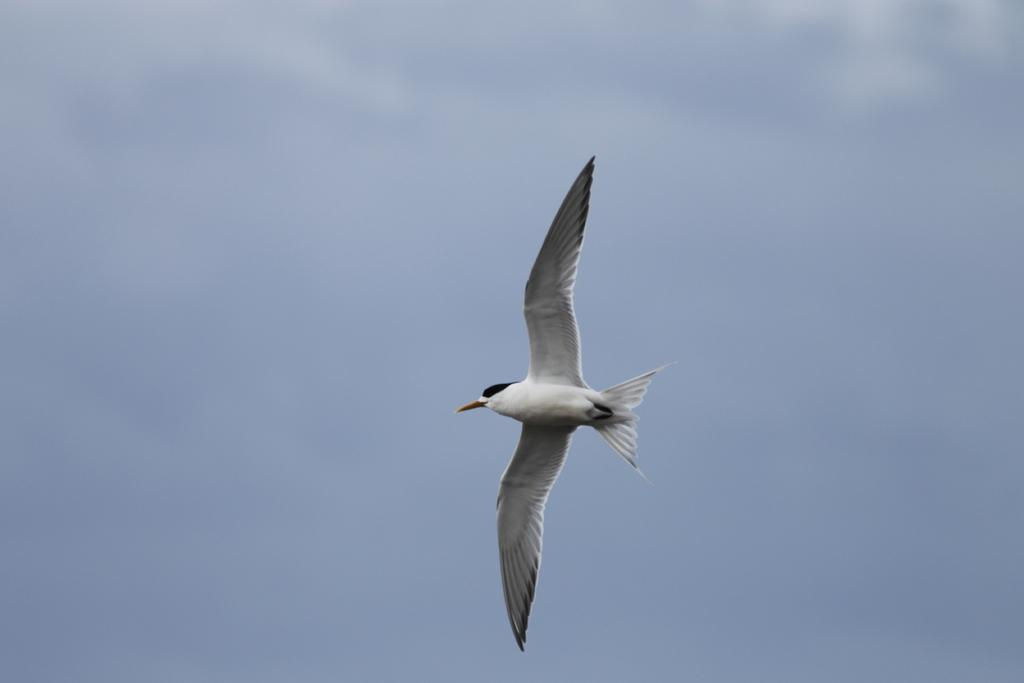What type of animal can be seen in the image? There is a white-colored bird in the image. Where is the bird located in the image? The bird is in the air. What can be seen in the background of the image? The sky is visible in the background of the image. What type of twig is the bird holding in its beak in the image? There is no twig visible in the image; the bird is simply flying in the air. 